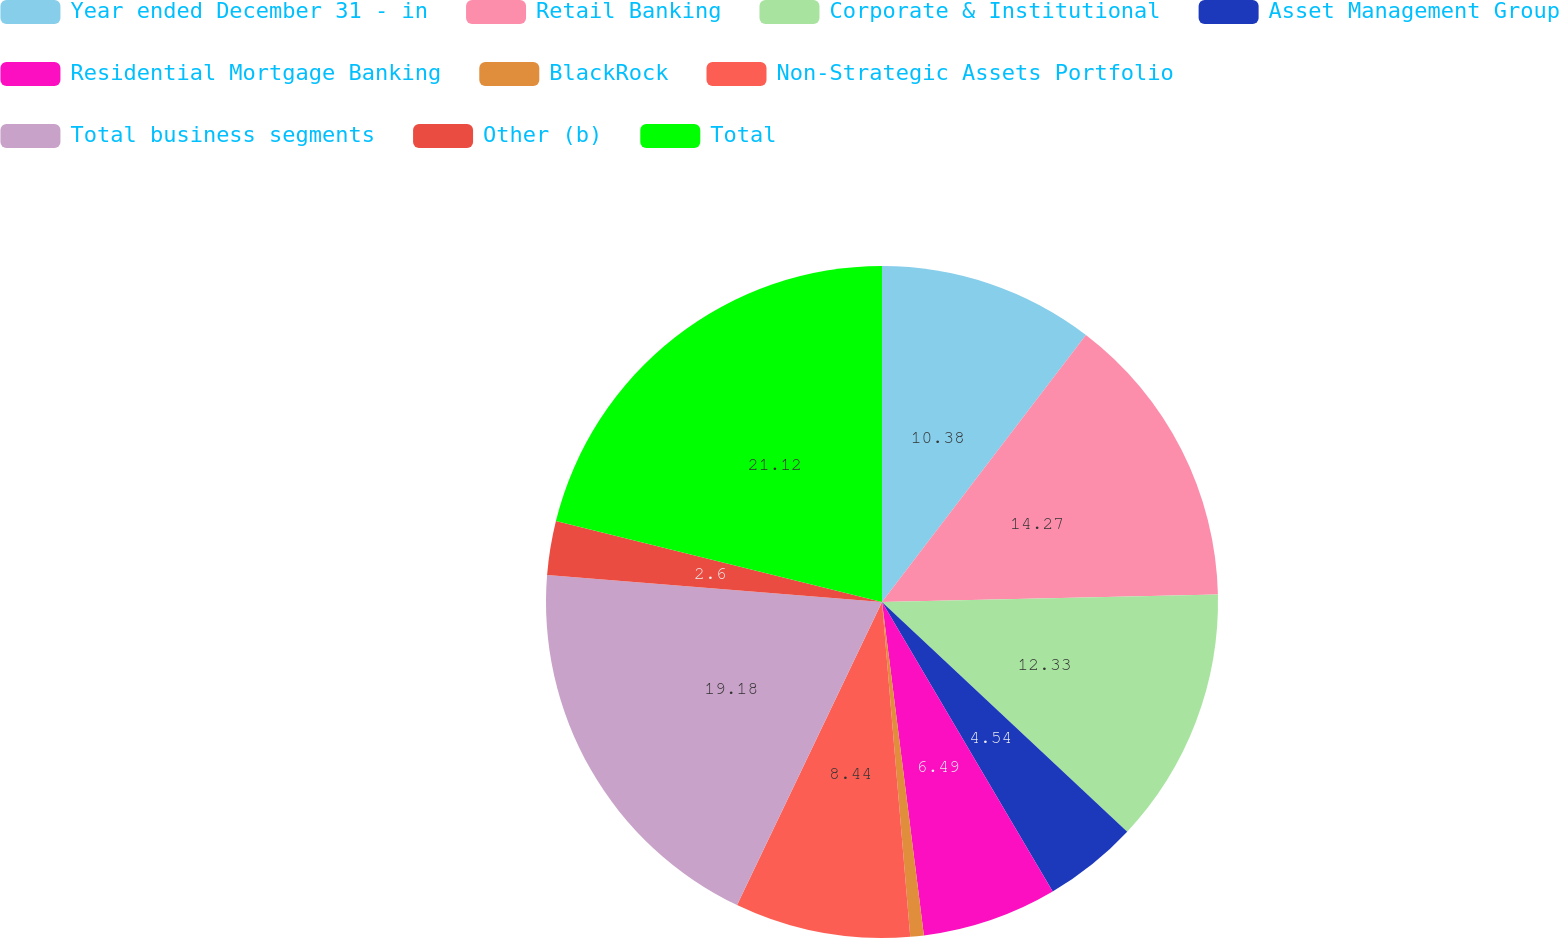Convert chart. <chart><loc_0><loc_0><loc_500><loc_500><pie_chart><fcel>Year ended December 31 - in<fcel>Retail Banking<fcel>Corporate & Institutional<fcel>Asset Management Group<fcel>Residential Mortgage Banking<fcel>BlackRock<fcel>Non-Strategic Assets Portfolio<fcel>Total business segments<fcel>Other (b)<fcel>Total<nl><fcel>10.38%<fcel>14.27%<fcel>12.33%<fcel>4.54%<fcel>6.49%<fcel>0.65%<fcel>8.44%<fcel>19.18%<fcel>2.6%<fcel>21.12%<nl></chart> 